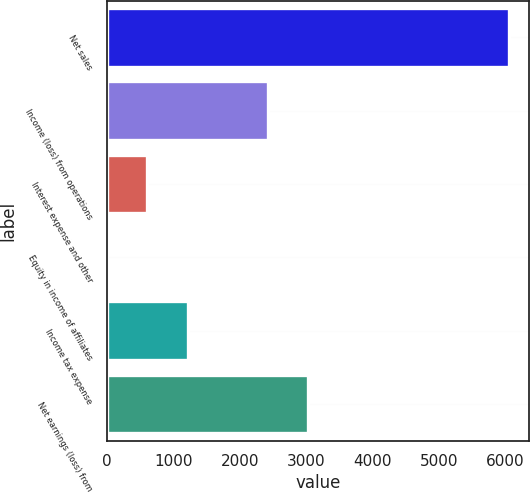<chart> <loc_0><loc_0><loc_500><loc_500><bar_chart><fcel>Net sales<fcel>Income (loss) from operations<fcel>Interest expense and other<fcel>Equity in income of affiliates<fcel>Income tax expense<fcel>Net earnings (loss) from<nl><fcel>6047<fcel>2423<fcel>611<fcel>7<fcel>1215<fcel>3027<nl></chart> 